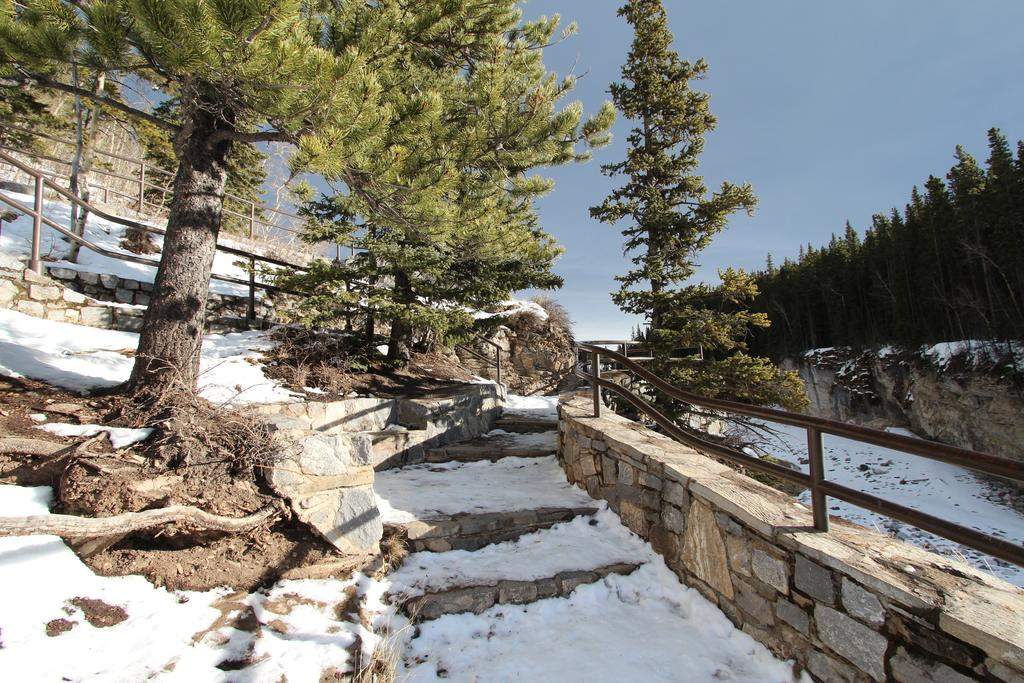What is covering the ground in the image? There is snow on the ground in the image. What type of structure can be seen in the image? There is a stone wall in the image. What type of vegetation is present in the image? There are trees in the image. What type of barrier is visible in the image? There is a fence in the image. What can be seen in the background of the image? The sky is visible in the background of the image. What type of fuel is being used by the police car in the image? There is no police car present in the image, so it is not possible to determine what type of fuel is being used. 